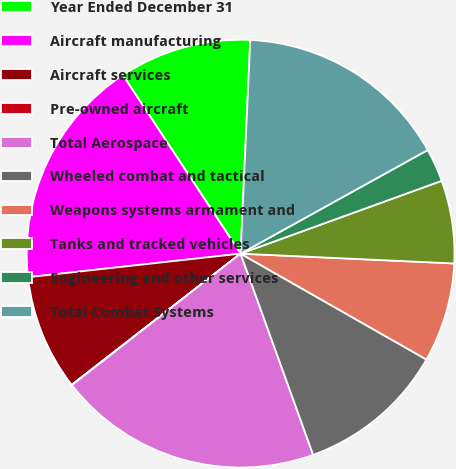Convert chart. <chart><loc_0><loc_0><loc_500><loc_500><pie_chart><fcel>Year Ended December 31<fcel>Aircraft manufacturing<fcel>Aircraft services<fcel>Pre-owned aircraft<fcel>Total Aerospace<fcel>Wheeled combat and tactical<fcel>Weapons systems armament and<fcel>Tanks and tracked vehicles<fcel>Engineering and other services<fcel>Total Combat Systems<nl><fcel>10.0%<fcel>17.48%<fcel>8.75%<fcel>0.03%<fcel>19.97%<fcel>11.25%<fcel>7.51%<fcel>6.26%<fcel>2.52%<fcel>16.23%<nl></chart> 